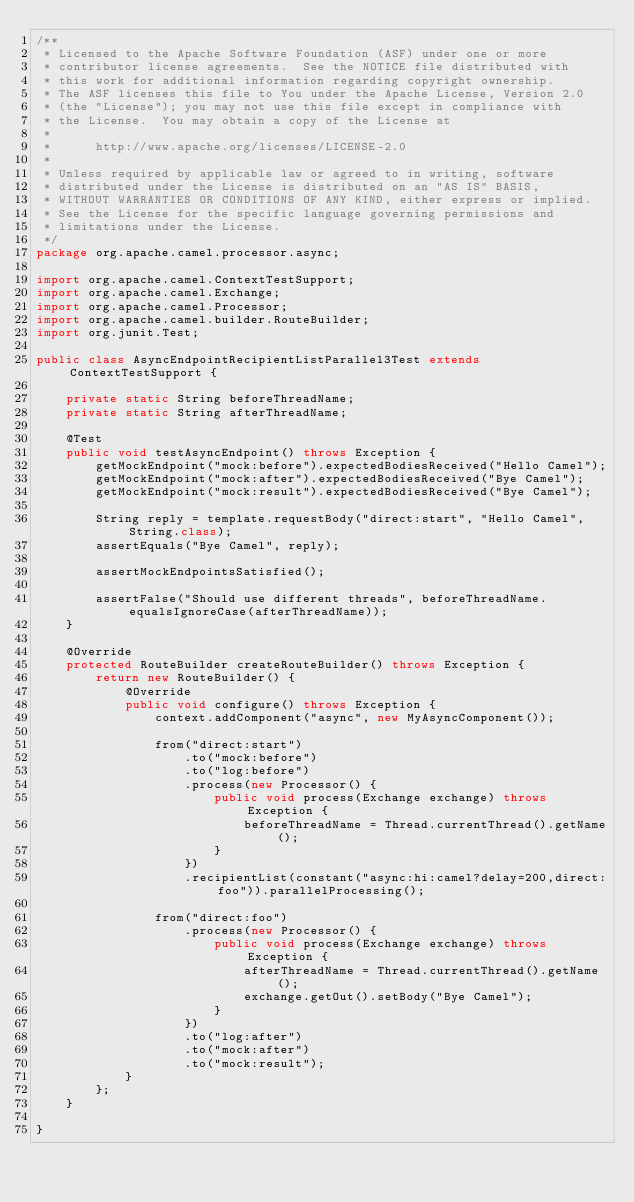<code> <loc_0><loc_0><loc_500><loc_500><_Java_>/**
 * Licensed to the Apache Software Foundation (ASF) under one or more
 * contributor license agreements.  See the NOTICE file distributed with
 * this work for additional information regarding copyright ownership.
 * The ASF licenses this file to You under the Apache License, Version 2.0
 * (the "License"); you may not use this file except in compliance with
 * the License.  You may obtain a copy of the License at
 *
 *      http://www.apache.org/licenses/LICENSE-2.0
 *
 * Unless required by applicable law or agreed to in writing, software
 * distributed under the License is distributed on an "AS IS" BASIS,
 * WITHOUT WARRANTIES OR CONDITIONS OF ANY KIND, either express or implied.
 * See the License for the specific language governing permissions and
 * limitations under the License.
 */
package org.apache.camel.processor.async;

import org.apache.camel.ContextTestSupport;
import org.apache.camel.Exchange;
import org.apache.camel.Processor;
import org.apache.camel.builder.RouteBuilder;
import org.junit.Test;

public class AsyncEndpointRecipientListParallel3Test extends ContextTestSupport {

    private static String beforeThreadName;
    private static String afterThreadName;

    @Test
    public void testAsyncEndpoint() throws Exception {
        getMockEndpoint("mock:before").expectedBodiesReceived("Hello Camel");
        getMockEndpoint("mock:after").expectedBodiesReceived("Bye Camel");
        getMockEndpoint("mock:result").expectedBodiesReceived("Bye Camel");

        String reply = template.requestBody("direct:start", "Hello Camel", String.class);
        assertEquals("Bye Camel", reply);

        assertMockEndpointsSatisfied();

        assertFalse("Should use different threads", beforeThreadName.equalsIgnoreCase(afterThreadName));
    }

    @Override
    protected RouteBuilder createRouteBuilder() throws Exception {
        return new RouteBuilder() {
            @Override
            public void configure() throws Exception {
                context.addComponent("async", new MyAsyncComponent());

                from("direct:start")
                    .to("mock:before")
                    .to("log:before")
                    .process(new Processor() {
                        public void process(Exchange exchange) throws Exception {
                            beforeThreadName = Thread.currentThread().getName();
                        }
                    })
                    .recipientList(constant("async:hi:camel?delay=200,direct:foo")).parallelProcessing();

                from("direct:foo")
                    .process(new Processor() {
                        public void process(Exchange exchange) throws Exception {
                            afterThreadName = Thread.currentThread().getName();
                            exchange.getOut().setBody("Bye Camel");
                        }
                    })
                    .to("log:after")
                    .to("mock:after")
                    .to("mock:result");
            }
        };
    }

}</code> 